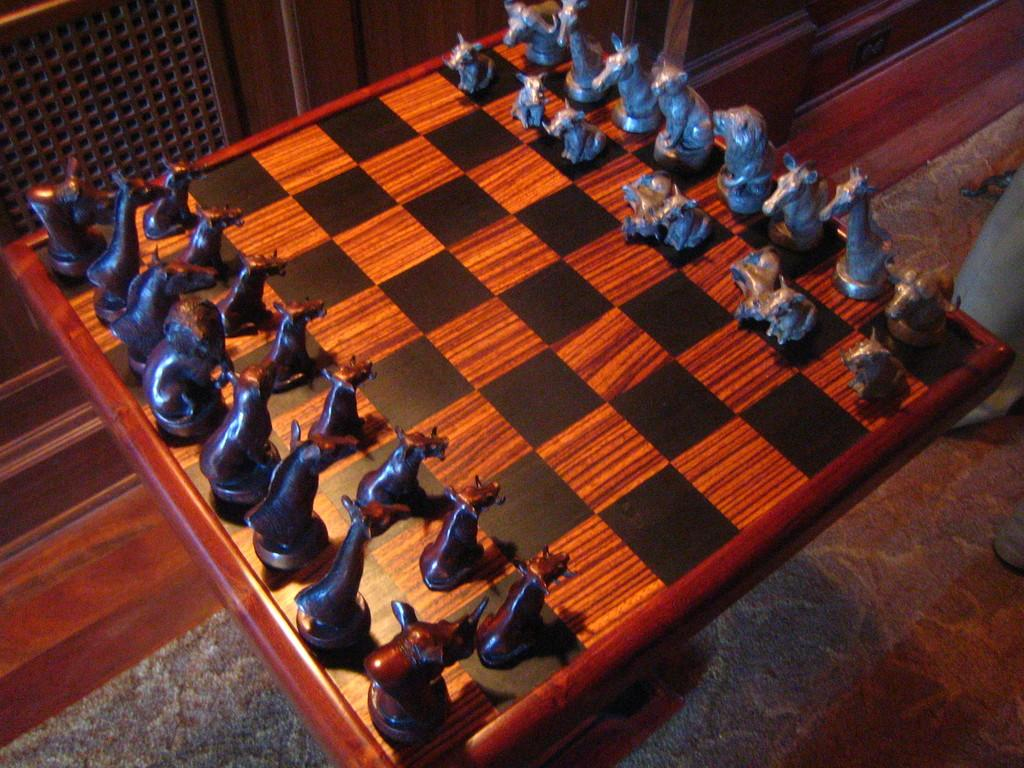What is the main subject of the image? The main subject of the image is a chess board. Are there any chess pieces on the chess board? Yes, there are chess pieces on the chess board. What can be seen in the background of the image? The background of the image appears to be a wall. How many bikes are leaning against the wall in the image? There are no bikes present in the image; it only features a chess board and chess pieces. What type of dress is the person wearing in the image? There is no person or dress present in the image; it only features a chess board and chess pieces. 